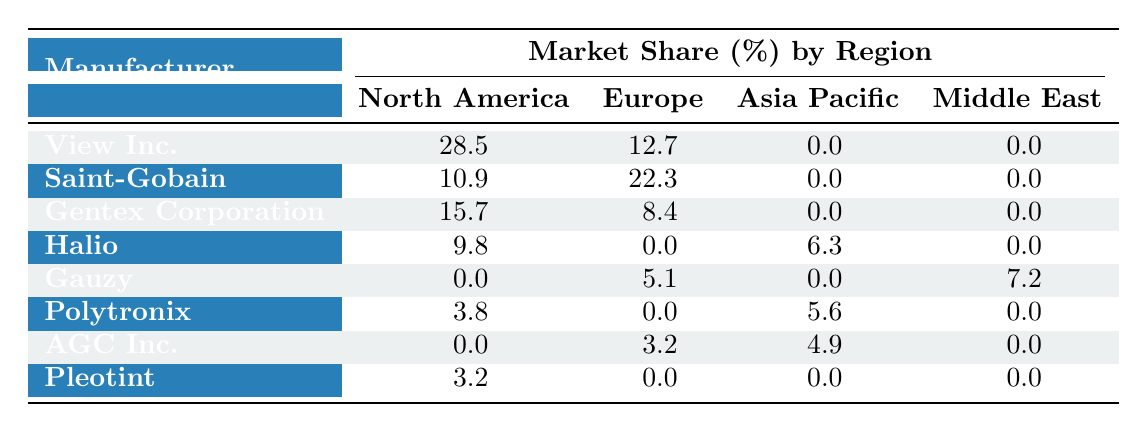What is the market share of View Inc. in North America? In the table, the market share of View Inc. in the North America row is listed as 28.5%.
Answer: 28.5% Which manufacturer has the highest market share in Europe? Looking at the Europe column, Saint-Gobain has the highest market share with 22.3%.
Answer: Saint-Gobain What is the total market share for Halio across all regions? Halio's market shares are 9.8% in North America and 6.3% in Asia Pacific. Adding these gives 9.8 + 6.3 = 16.1%.
Answer: 16.1% Is Gauzy's market share in the Middle East greater than its market share in Europe? Gauzy has a market share of 7.2% in the Middle East and 5.1% in Europe. Since 7.2 is greater than 5.1, the statement is true.
Answer: Yes What is the combined market share of Polytronix in Asia Pacific and North America? Polytronix has a market share of 5.6% in Asia Pacific and 3.8% in North America. Adding these values gives 5.6 + 3.8 = 9.4%.
Answer: 9.4% Which manufacturer has a market share greater than 10% in any of the regions? Upon reviewing the table, View Inc. in North America (28.5%) and Saint-Gobain in Europe (22.3%) have market shares greater than 10%.
Answer: Yes Calculate the average market share of all manufacturers in Asia Pacific. There are two manufacturers listed in Asia Pacific: Polytronix with 5.6% and AGC Inc. with 4.9%. To find the average, sum the values (5.6 + 4.9 = 10.5) and divide by the number of manufacturers (2). So, the average market share is 10.5 / 2 = 5.25%.
Answer: 5.25% 